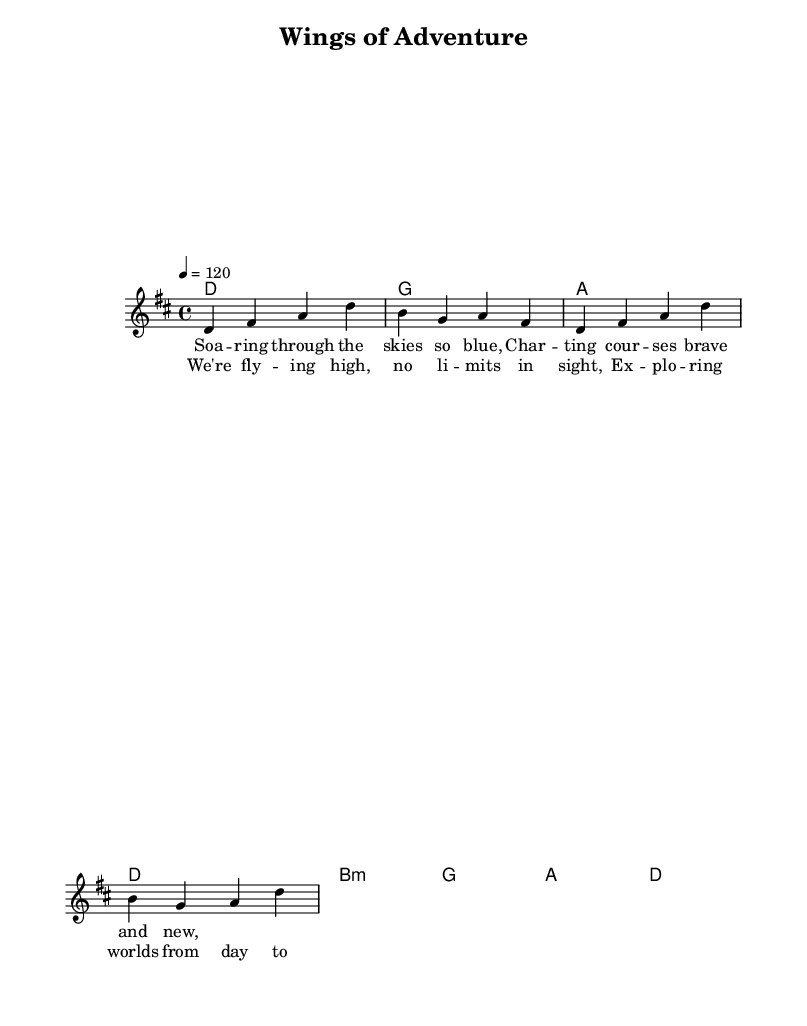What is the key signature of this music? The key signature is D major, which has two sharps (F# and C#). This is indicated at the beginning of the staff.
Answer: D major What is the time signature of this music? The time signature is 4/4, meaning there are four beats in a measure and the quarter note gets one beat. This is also found at the start of the staff.
Answer: 4/4 What is the tempo marking for this piece? The tempo marking is "4 = 120," which means the quarter note is played at a speed of 120 beats per minute. This is written above the staff.
Answer: 120 What are the lyrics for the chorus? The lyrics for the chorus are "We're fly -- ing high, no li -- mits in sight, Ex -- plo -- ring worlds from day to night." This section is labeled as the chorus in the song structure.
Answer: "We're fly -- ing high, no li -- mits in sight, Ex -- plo -- ring worlds from day to night." How many measures are in the melody? The melody section contains 4 measures, visible by the bar lines that separate the music into distinct segments. Each measure contains the respective notes written in them.
Answer: 4 What chord follows the D major chord in the harmonies? The chord following the D major chord is B minor, which is in the same measure and is the next chord indicated in the chord mode sequence.
Answer: B minor 